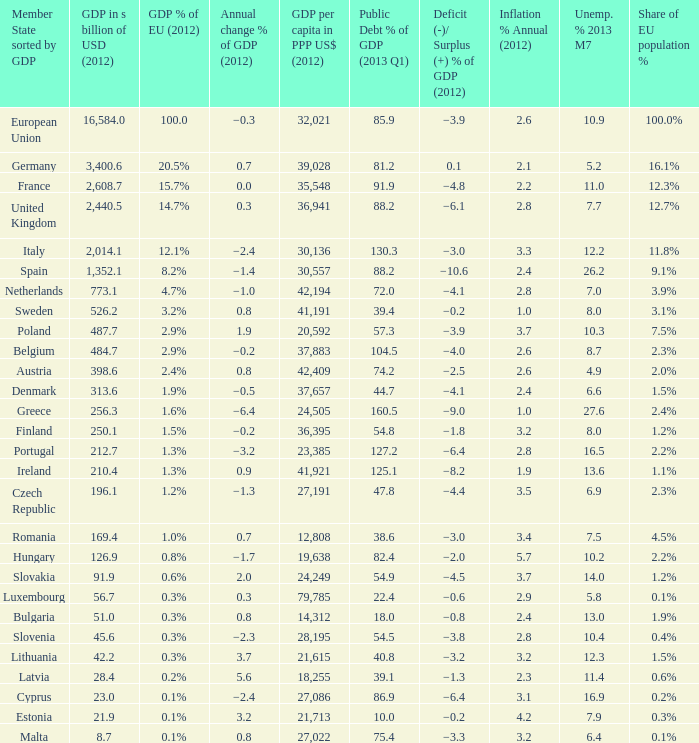What is the largest inflation % annual in 2012 of the country with a public debt % of GDP in 2013 Q1 greater than 88.2 and a GDP % of EU in 2012 of 2.9%? 2.6. 